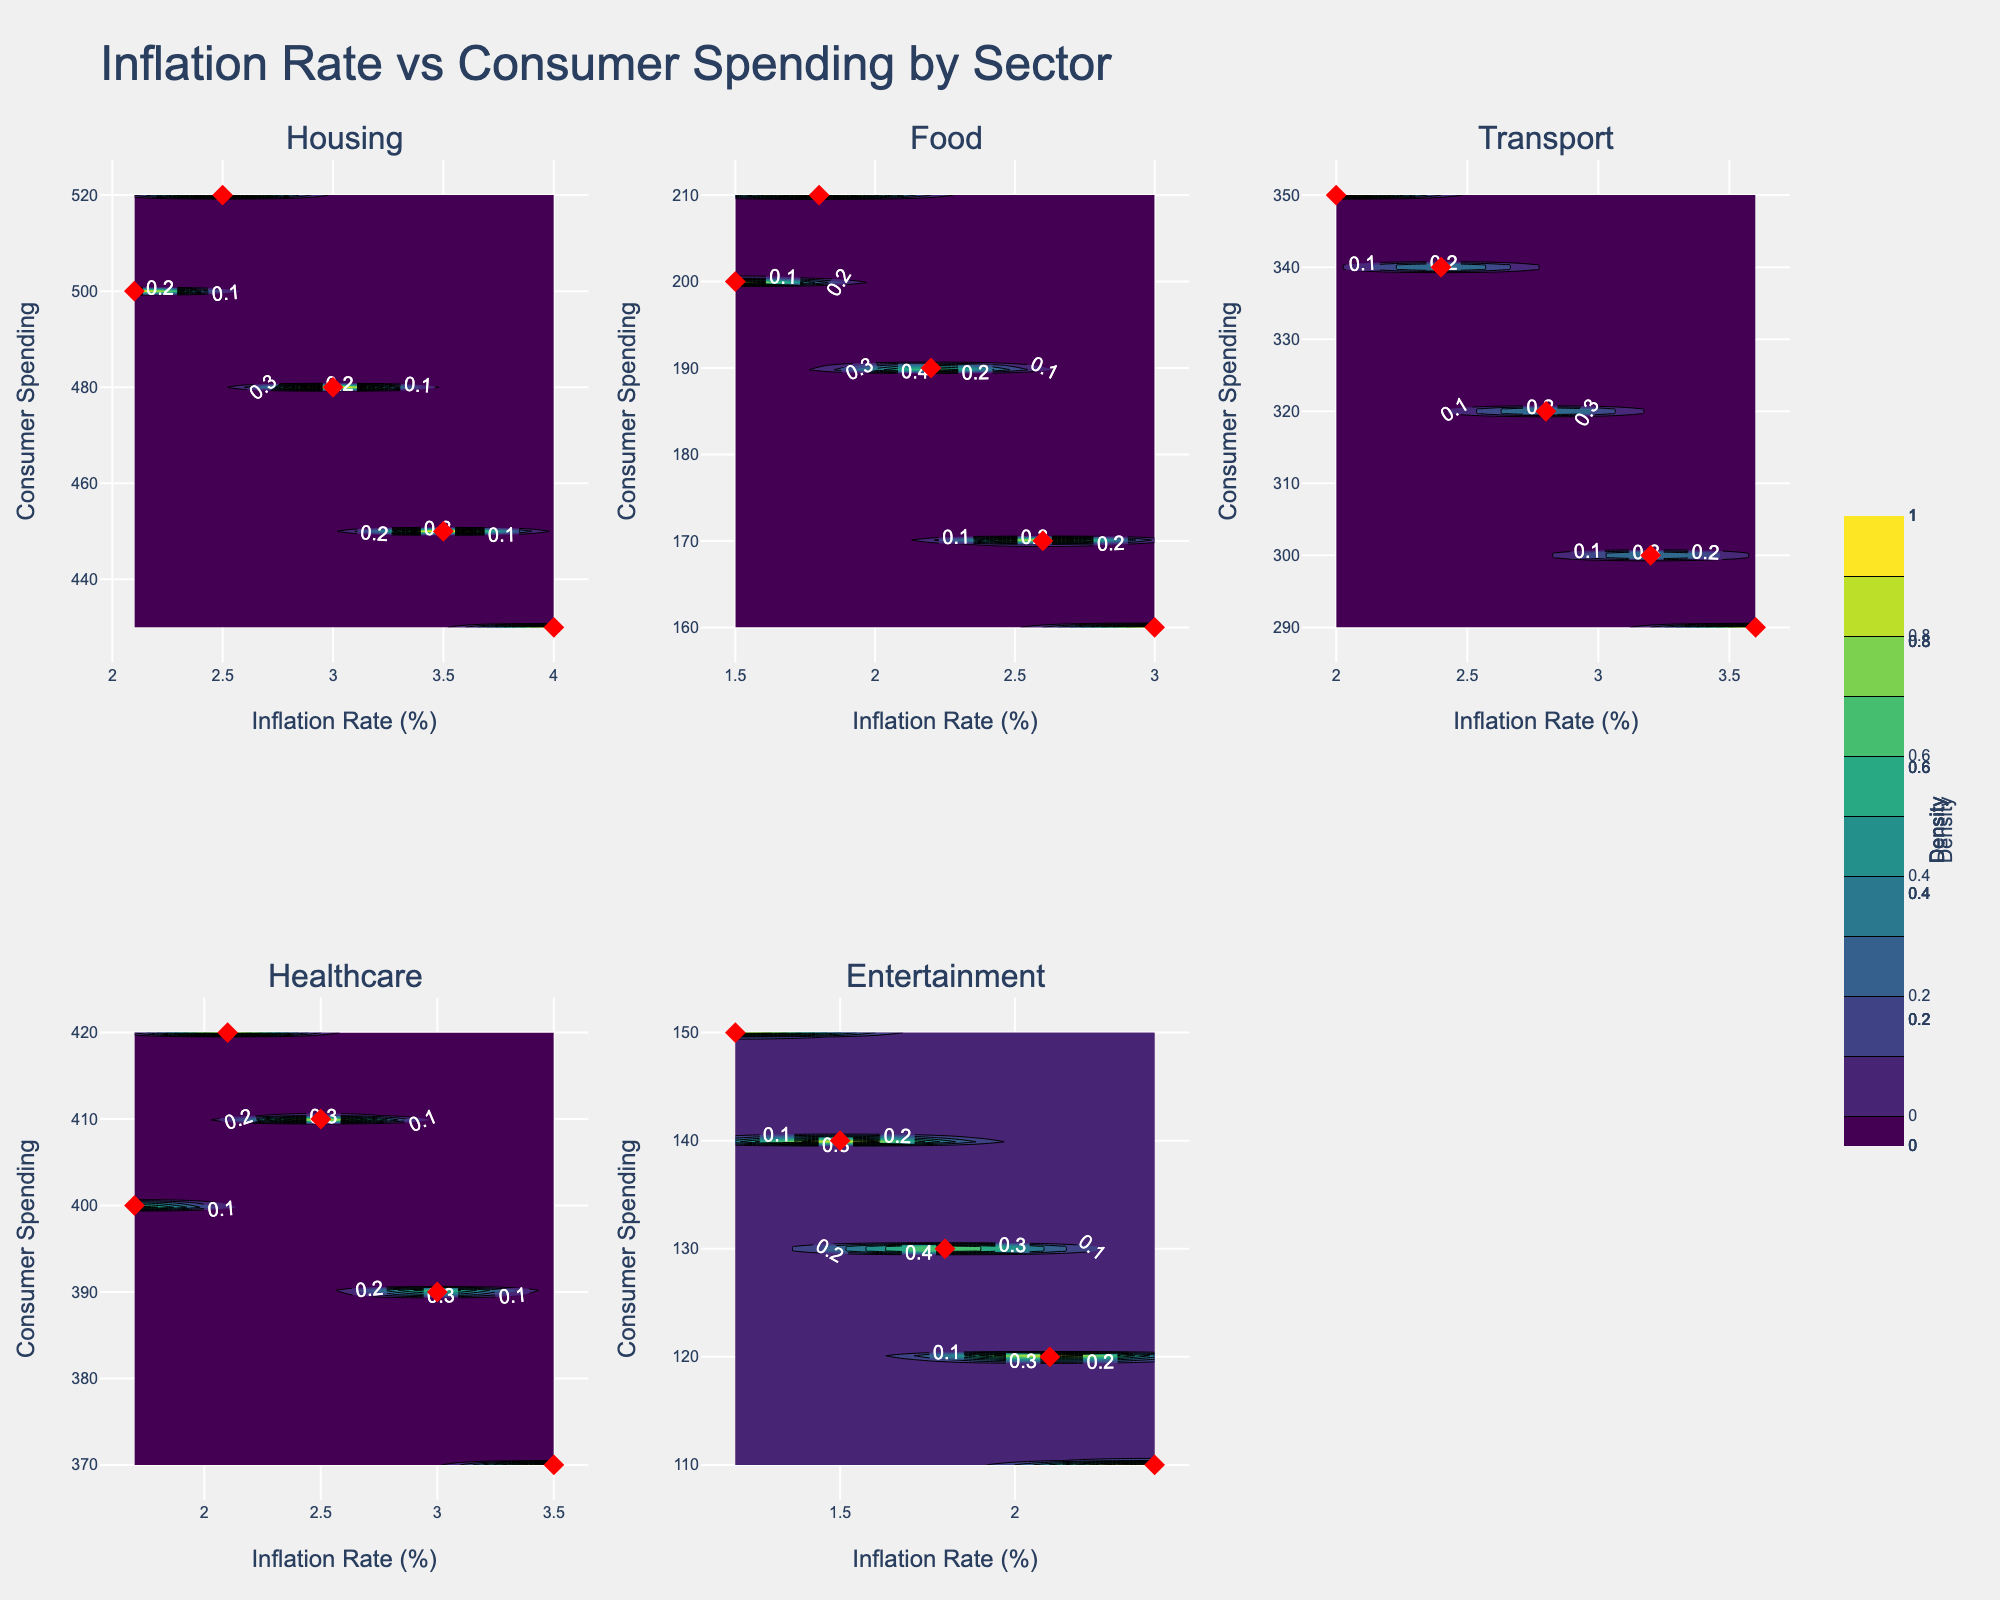What is the title of the figure? The title is prominently displayed at the top of the figure. It gives an overview of what the figure is depicting.
Answer: Inflation Rate vs Consumer Spending by Sector How many subplots are there in total? The figure is divided into smaller plots for each sector. You can count the individual plots.
Answer: Six Which sector shows the lowest maximum Consumer Spending? Look at the maximum Consumer Spending value on the y-axis for each sector and identify the lowest one.
Answer: Entertainment What is the approximate Consumer Spending at an Inflation Rate of 3.5% for the Housing sector? Locate the Housing sector subplot and find the point where the Inflation Rate is 3.5%, then find the corresponding Consumer Spending on the y-axis.
Answer: 450 Compare the trend of Consumer Spending with increasing Inflation Rate in the Food sector versus the Transport sector. Examine the contours and data points in the subplots for Food and Transport. Notice how Consumer Spending changes with Inflation Rate in both sectors. In Food, Consumer Spending decreases more sharply with increasing Inflation Rate compared to Transport.
Answer: Consumer Spending in Food decreases more sharply with increasing Inflation Rate compared to Transport Which sector has the most spread out Consumer Spending values? Look at the range of Consumer Spending values on the y-axis for each sector and identify which one has the broadest range.
Answer: Housing What does the color gradient represent in each of the subplots? The legend and color scale indicate what the color gradient represents, which in this case is density.
Answer: Density In the Healthcare sector, what happens to Consumer Spending when Inflation Rate exceeds 3.0%? Locate the Healthcare sector subplot and observe the trend of Consumer Spending values when Inflation Rate goes beyond 3.0%. Consumer Spending decreases.
Answer: Consumer Spending decreases Rank the sectors based on their maximum Inflations Rates from highest to lowest. Look at the maximum Inflation Rate value on the x-axis for each sector and sort them accordingly.
Answer: Housing, Food, Transport, Healthcare, Entertainment Do any sectors show a pattern where Consumer Spending increases with an increasing Inflation Rate? If so, which ones? Examine each subplot to see if there is an increasing trend in Consumer Spending as Inflation Rate increases.
Answer: No sectors show this pattern 